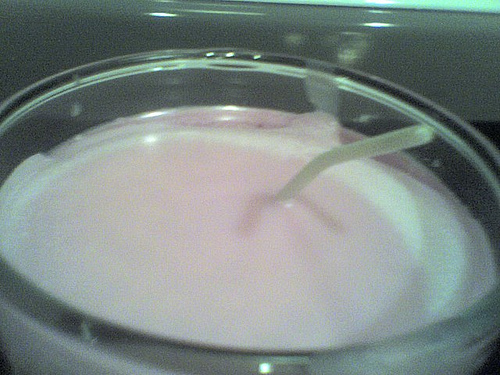<image>
Is there a bed next to the bed? No. The bed is not positioned next to the bed. They are located in different areas of the scene. 